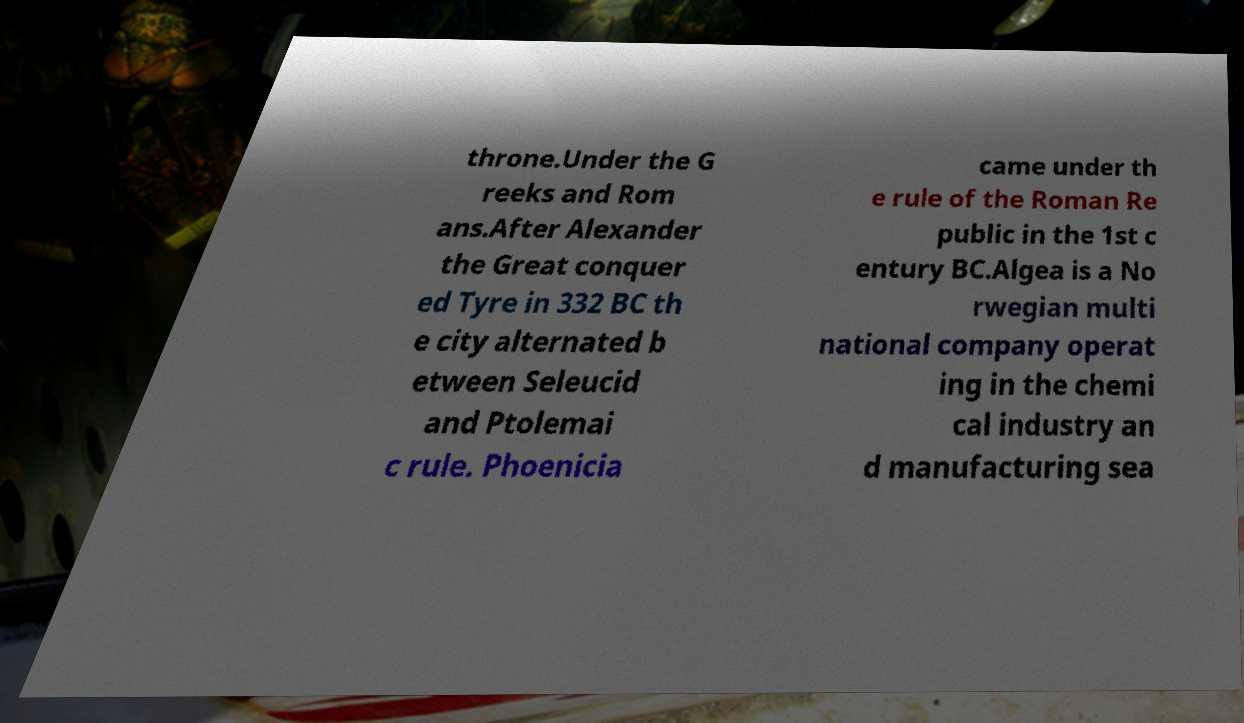For documentation purposes, I need the text within this image transcribed. Could you provide that? throne.Under the G reeks and Rom ans.After Alexander the Great conquer ed Tyre in 332 BC th e city alternated b etween Seleucid and Ptolemai c rule. Phoenicia came under th e rule of the Roman Re public in the 1st c entury BC.Algea is a No rwegian multi national company operat ing in the chemi cal industry an d manufacturing sea 